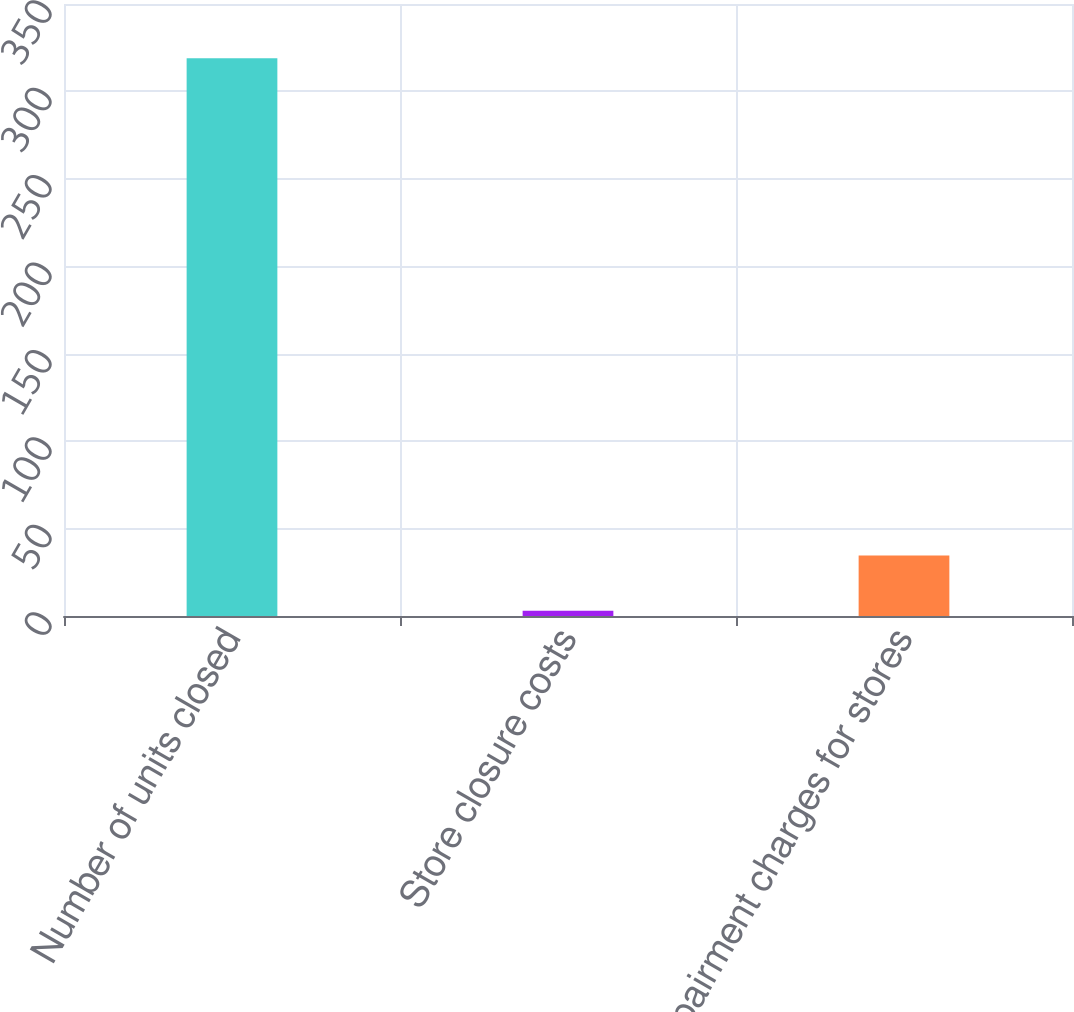Convert chart to OTSL. <chart><loc_0><loc_0><loc_500><loc_500><bar_chart><fcel>Number of units closed<fcel>Store closure costs<fcel>Impairment charges for stores<nl><fcel>319<fcel>3<fcel>34.6<nl></chart> 